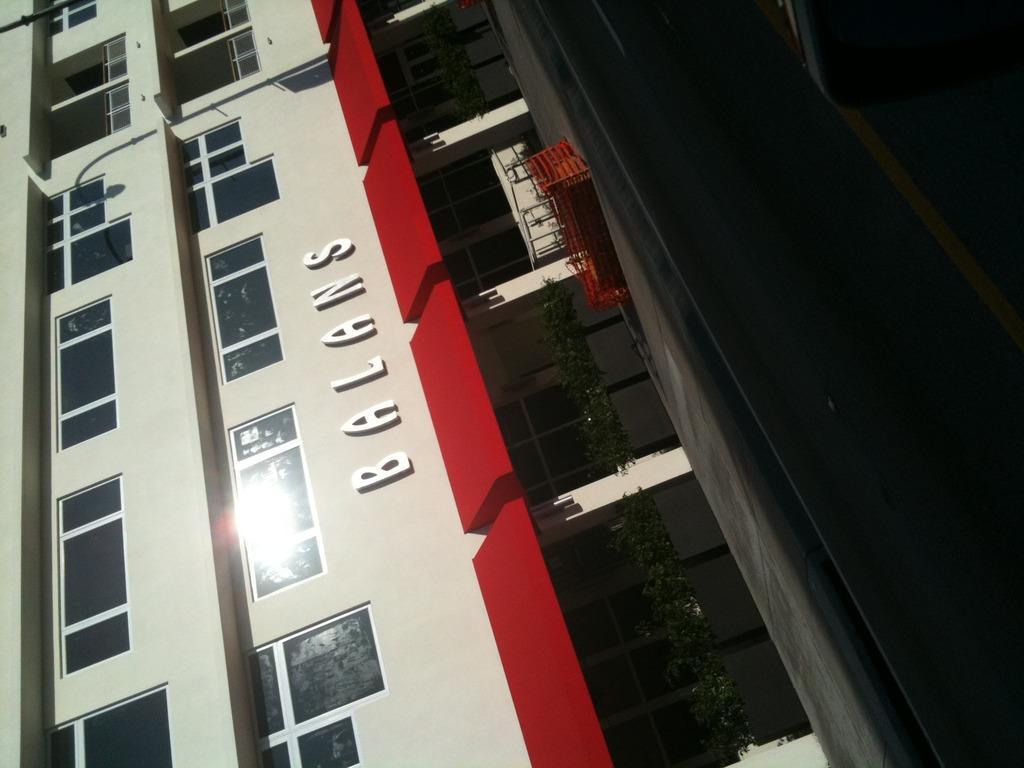Describe this image in one or two sentences. In the given image i can see a building with windows and some text on it. 